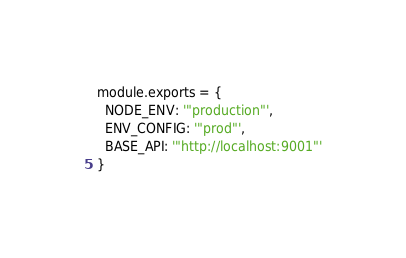<code> <loc_0><loc_0><loc_500><loc_500><_JavaScript_>module.exports = {
  NODE_ENV: '"production"',
  ENV_CONFIG: '"prod"',
  BASE_API: '"http://localhost:9001"'
}
</code> 